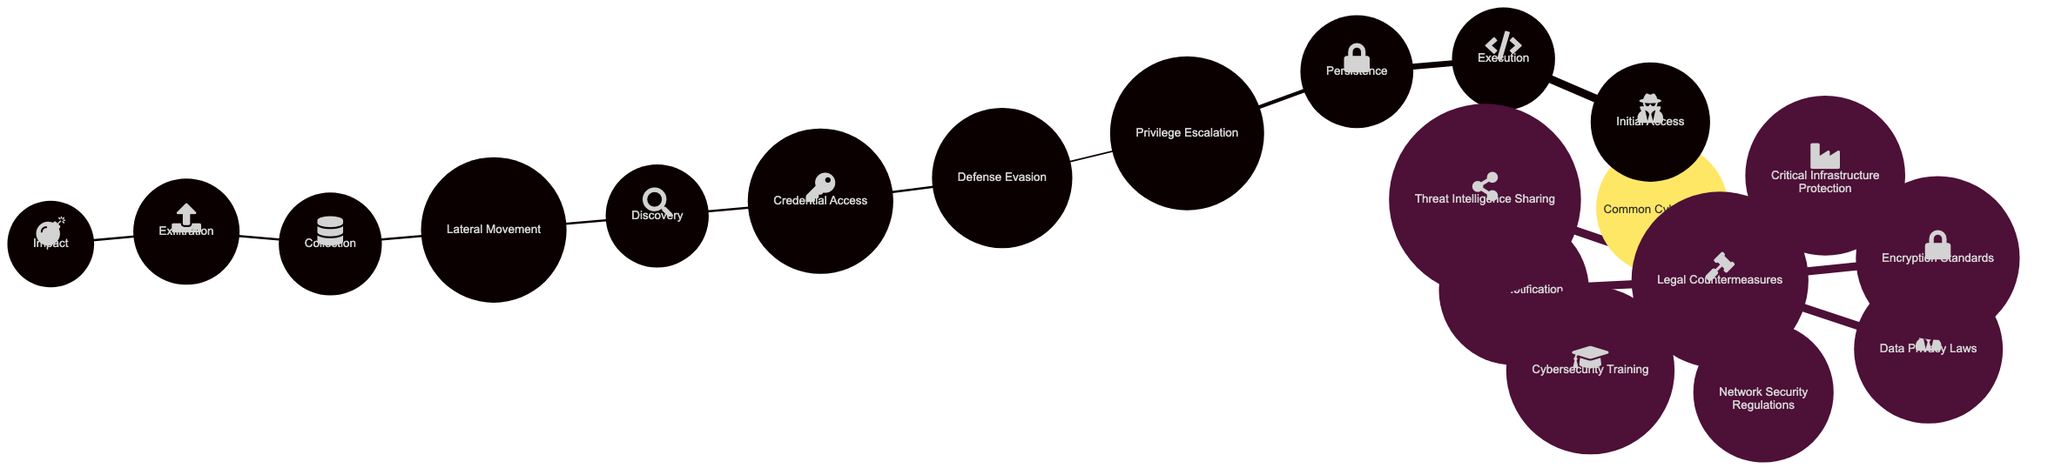What is the first stage in a common cyber attack? The diagram identifies "Initial Access" as the first stage of a common cyber attack, which is the starting point of the attack sequence.
Answer: Initial Access How many stages are listed in the "Common Cyber Attack" section? By counting the nodes under "Common Cyber Attack," there are a total of 11 mentioned stages in the process, including "Initial Access" and "Impact."
Answer: 11 What legal countermeasure addresses the sharing of threat data? The node labeled "Threat Intelligence Sharing" directly refers to the legal countermeasure focused on the sharing of information regarding threats.
Answer: Threat Intelligence Sharing Which two nodes represent actions taken during the attack phase? The nodes "Execution" and "Credential Access" both specifically refer to actions performed by the attacker during the attack phase.
Answer: Execution, Credential Access What node follows "Privilege Escalation" in the attack path? In the attack path, "Defense Evasion" directly follows "Privilege Escalation," indicating the sequence of actions taken in the attack.
Answer: Defense Evasion How many legal countermeasures are listed in the diagram? The diagram lists 7 legal countermeasures, indicating the regulatory aspects to counter cyber threats effectively.
Answer: 7 What is the endpoint of the attack sequence? According to the diagram, the endpoint of the attack sequence is represented as "Impact," which signifies the final outcome of the cyber attack.
Answer: Impact Which legal countermeasure involves regulations regarding cybersecurity practices? "Network Security Regulations" is the legal countermeasure that encompasses standards and regulations for maintaining cybersecurity practices.
Answer: Network Security Regulations What is the relationship between "Exfiltration" and "Collection"? "Exfiltration" follows "Collection," indicating that the process of collecting data is prior to the actual exfiltration of data from the system.
Answer: Exfiltration follows Collection 